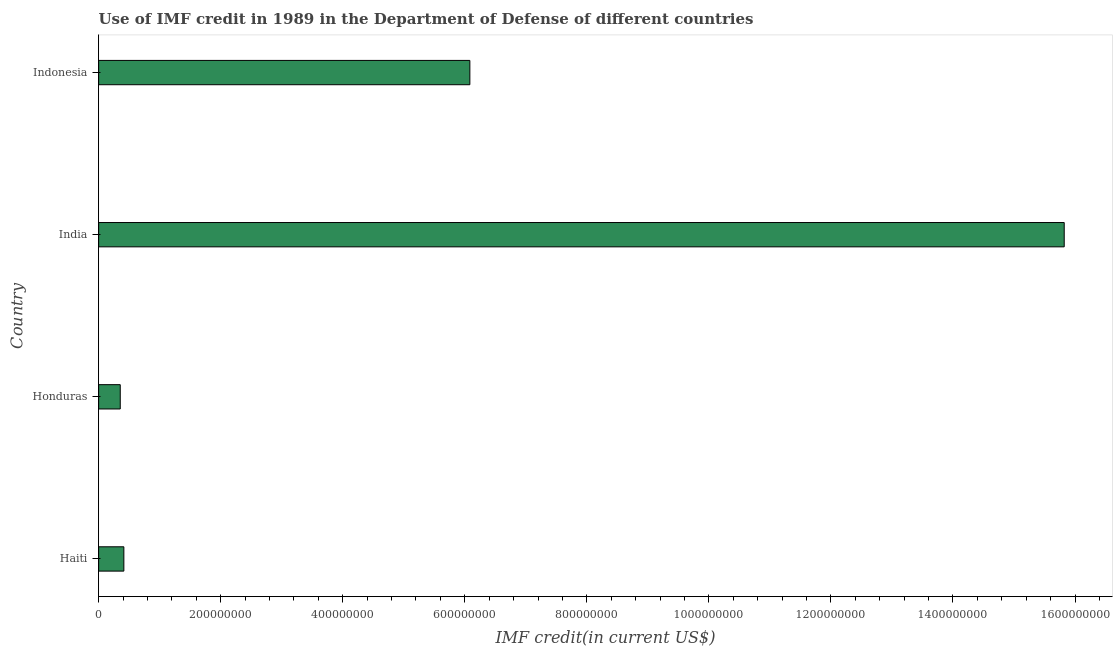Does the graph contain grids?
Keep it short and to the point. No. What is the title of the graph?
Keep it short and to the point. Use of IMF credit in 1989 in the Department of Defense of different countries. What is the label or title of the X-axis?
Keep it short and to the point. IMF credit(in current US$). What is the use of imf credit in dod in India?
Provide a short and direct response. 1.58e+09. Across all countries, what is the maximum use of imf credit in dod?
Provide a short and direct response. 1.58e+09. Across all countries, what is the minimum use of imf credit in dod?
Your response must be concise. 3.54e+07. In which country was the use of imf credit in dod maximum?
Provide a short and direct response. India. In which country was the use of imf credit in dod minimum?
Provide a short and direct response. Honduras. What is the sum of the use of imf credit in dod?
Offer a very short reply. 2.27e+09. What is the difference between the use of imf credit in dod in Haiti and Indonesia?
Your response must be concise. -5.67e+08. What is the average use of imf credit in dod per country?
Your answer should be compact. 5.67e+08. What is the median use of imf credit in dod?
Provide a short and direct response. 3.25e+08. What is the ratio of the use of imf credit in dod in Honduras to that in India?
Your answer should be very brief. 0.02. Is the difference between the use of imf credit in dod in Honduras and Indonesia greater than the difference between any two countries?
Provide a short and direct response. No. What is the difference between the highest and the second highest use of imf credit in dod?
Offer a terse response. 9.74e+08. What is the difference between the highest and the lowest use of imf credit in dod?
Provide a short and direct response. 1.55e+09. In how many countries, is the use of imf credit in dod greater than the average use of imf credit in dod taken over all countries?
Ensure brevity in your answer.  2. How many bars are there?
Keep it short and to the point. 4. Are all the bars in the graph horizontal?
Make the answer very short. Yes. How many countries are there in the graph?
Offer a very short reply. 4. What is the IMF credit(in current US$) of Haiti?
Ensure brevity in your answer.  4.13e+07. What is the IMF credit(in current US$) of Honduras?
Keep it short and to the point. 3.54e+07. What is the IMF credit(in current US$) in India?
Offer a very short reply. 1.58e+09. What is the IMF credit(in current US$) of Indonesia?
Your answer should be compact. 6.08e+08. What is the difference between the IMF credit(in current US$) in Haiti and Honduras?
Your answer should be very brief. 5.91e+06. What is the difference between the IMF credit(in current US$) in Haiti and India?
Your answer should be very brief. -1.54e+09. What is the difference between the IMF credit(in current US$) in Haiti and Indonesia?
Keep it short and to the point. -5.67e+08. What is the difference between the IMF credit(in current US$) in Honduras and India?
Give a very brief answer. -1.55e+09. What is the difference between the IMF credit(in current US$) in Honduras and Indonesia?
Provide a succinct answer. -5.73e+08. What is the difference between the IMF credit(in current US$) in India and Indonesia?
Your response must be concise. 9.74e+08. What is the ratio of the IMF credit(in current US$) in Haiti to that in Honduras?
Provide a succinct answer. 1.17. What is the ratio of the IMF credit(in current US$) in Haiti to that in India?
Give a very brief answer. 0.03. What is the ratio of the IMF credit(in current US$) in Haiti to that in Indonesia?
Offer a terse response. 0.07. What is the ratio of the IMF credit(in current US$) in Honduras to that in India?
Provide a short and direct response. 0.02. What is the ratio of the IMF credit(in current US$) in Honduras to that in Indonesia?
Give a very brief answer. 0.06. What is the ratio of the IMF credit(in current US$) in India to that in Indonesia?
Your response must be concise. 2.6. 